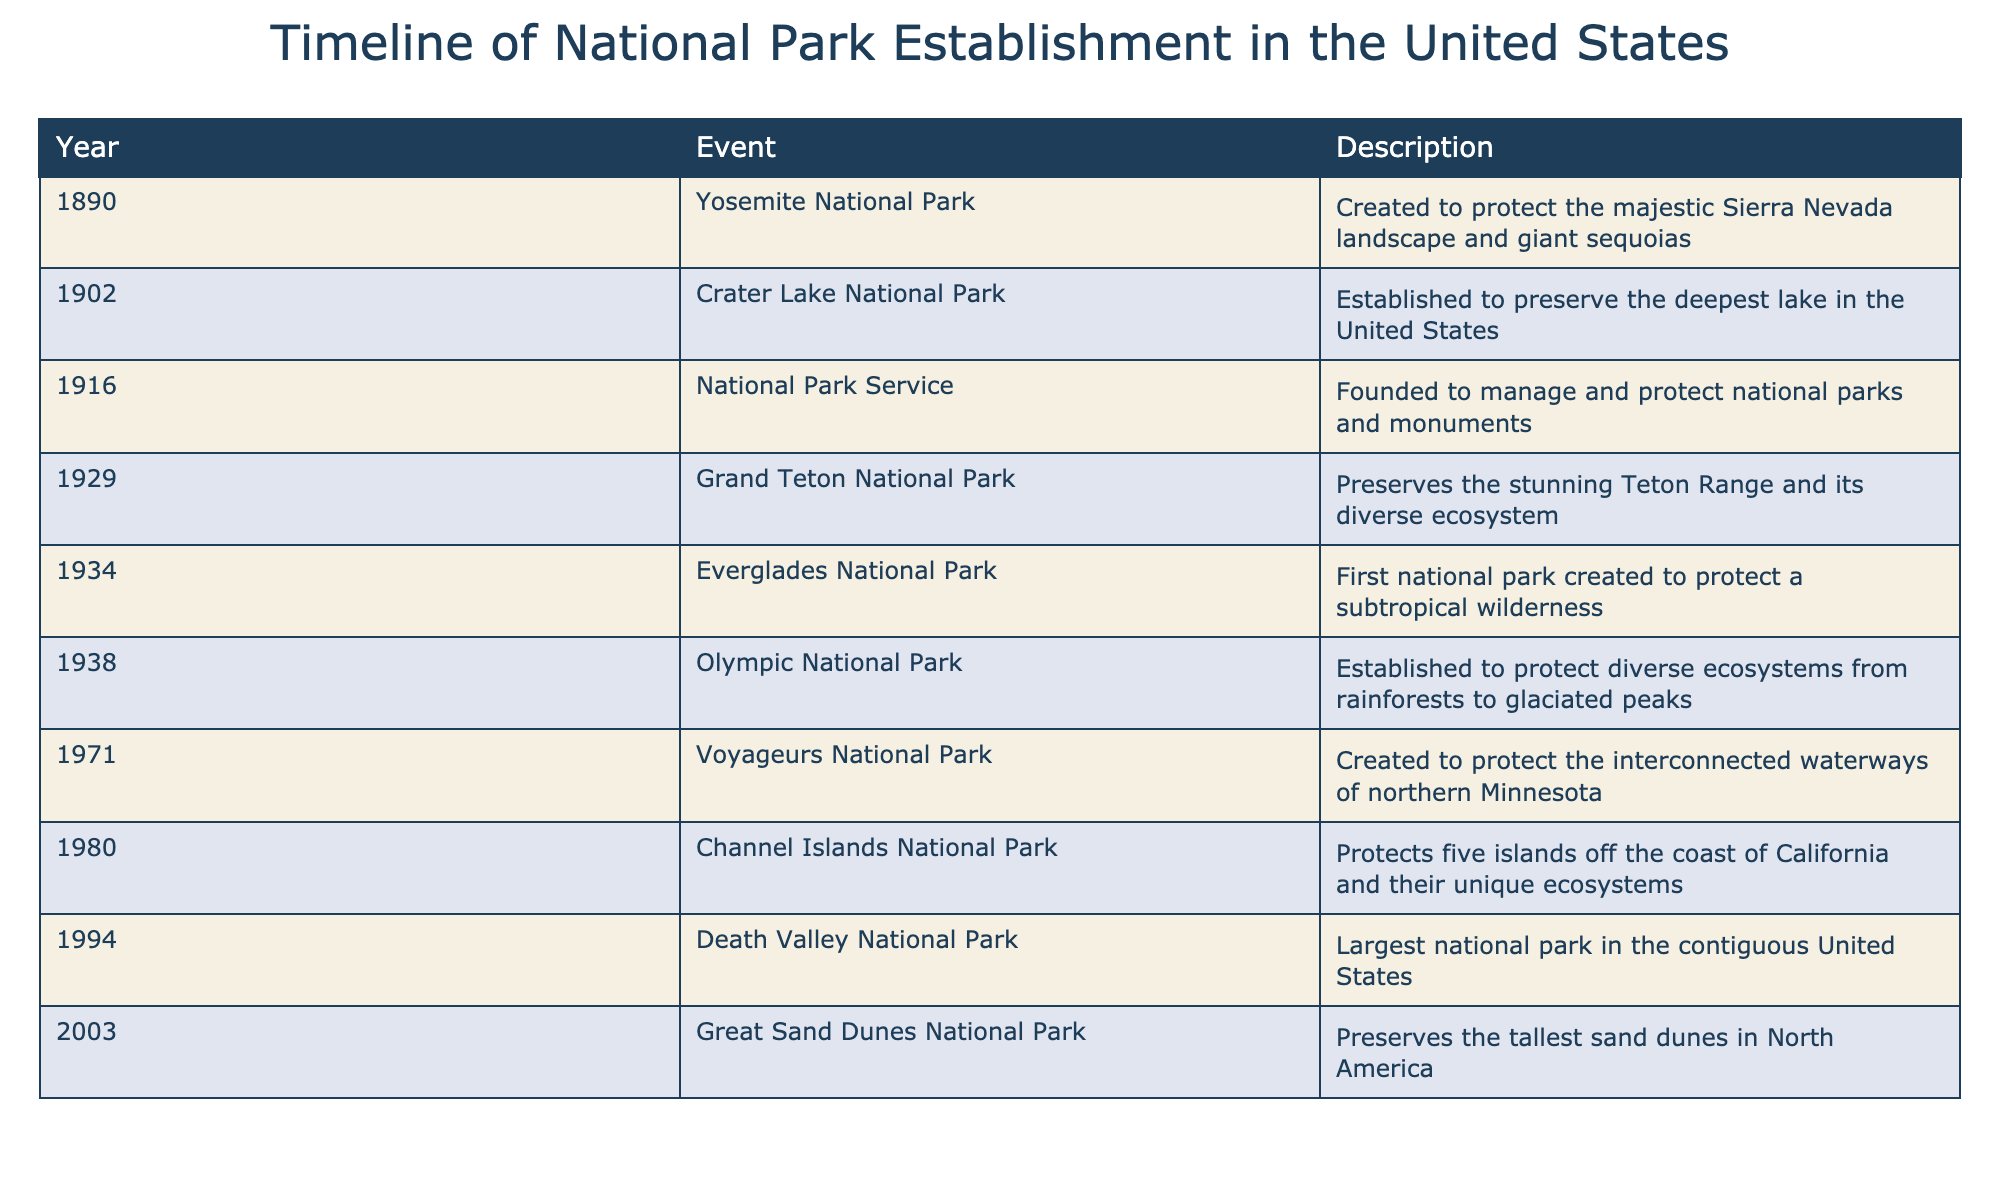What year was the National Park Service founded? The table specifically states that the National Park Service was founded in 1916. This is a direct retrieval from the event listed under that year in the table.
Answer: 1916 How many national parks were established before the year 1930? Looking at the table, the established national parks before 1930 are: Yosemite (1890), Crater Lake (1902), Grand Teton (1929), and Everglades (1934). Therefore, there are 3 parks established before 1930.
Answer: 3 Is Death Valley National Park the largest national park in the contiguous United States? According to the table, it mentions that Death Valley National Park is the largest national park in the contiguous United States, so this statement is true.
Answer: Yes Which national park was established most recently? The table lists Great Sand Dunes National Park as established in 2003, which is the latest date compared to other parks listed. Thus, it is the most recent national park established.
Answer: Great Sand Dunes National Park What is the difference in years between the establishment of Yosemite National Park and the National Park Service? Yosemite National Park was established in 1890 and the National Park Service in 1916. To find the difference, subtract 1890 from 1916, which gives 26 years.
Answer: 26 years How many national parks were established after 1970? From the table, the parks established after 1970 include 3: Voyageurs (1971), Channel Islands (1980), and Great Sand Dunes (2003). This means 3 parks were established after 1970.
Answer: 3 Are there any national parks established in the 1930s? The table indicates that there are two parks established in the 1930s: Everglades National Park in 1934 and Olympic National Park in 1938. Therefore, yes, there are national parks from this decade.
Answer: Yes How many years apart is the establishment of Crater Lake National Park from Channel Islands National Park? Crater Lake was established in 1902, while Channel Islands was established in 1980. To find the difference, compute 1980 minus 1902, which is 78 years.
Answer: 78 years Which park was created to preserve the tallest sand dunes in North America? According to the table, Great Sand Dunes National Park is explicitly mentioned as preserving the tallest sand dunes in North America.
Answer: Great Sand Dunes National Park 